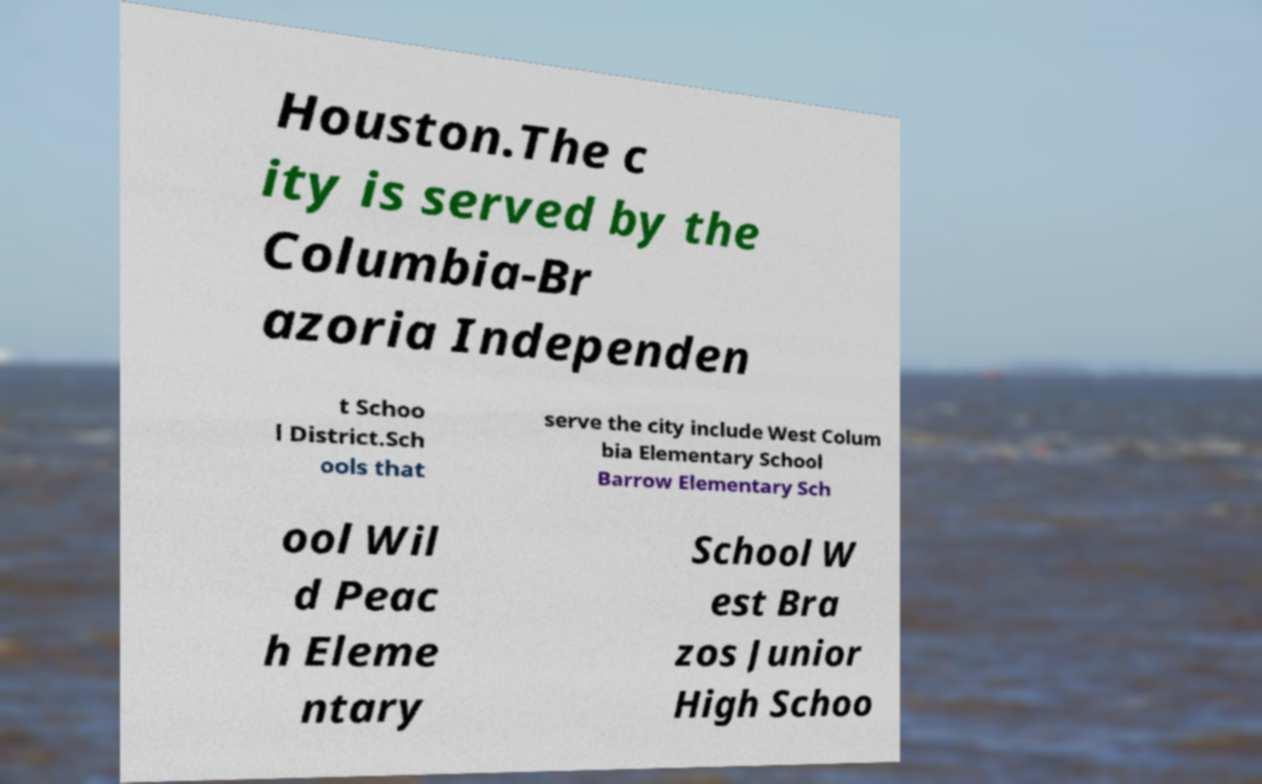For documentation purposes, I need the text within this image transcribed. Could you provide that? Houston.The c ity is served by the Columbia-Br azoria Independen t Schoo l District.Sch ools that serve the city include West Colum bia Elementary School Barrow Elementary Sch ool Wil d Peac h Eleme ntary School W est Bra zos Junior High Schoo 